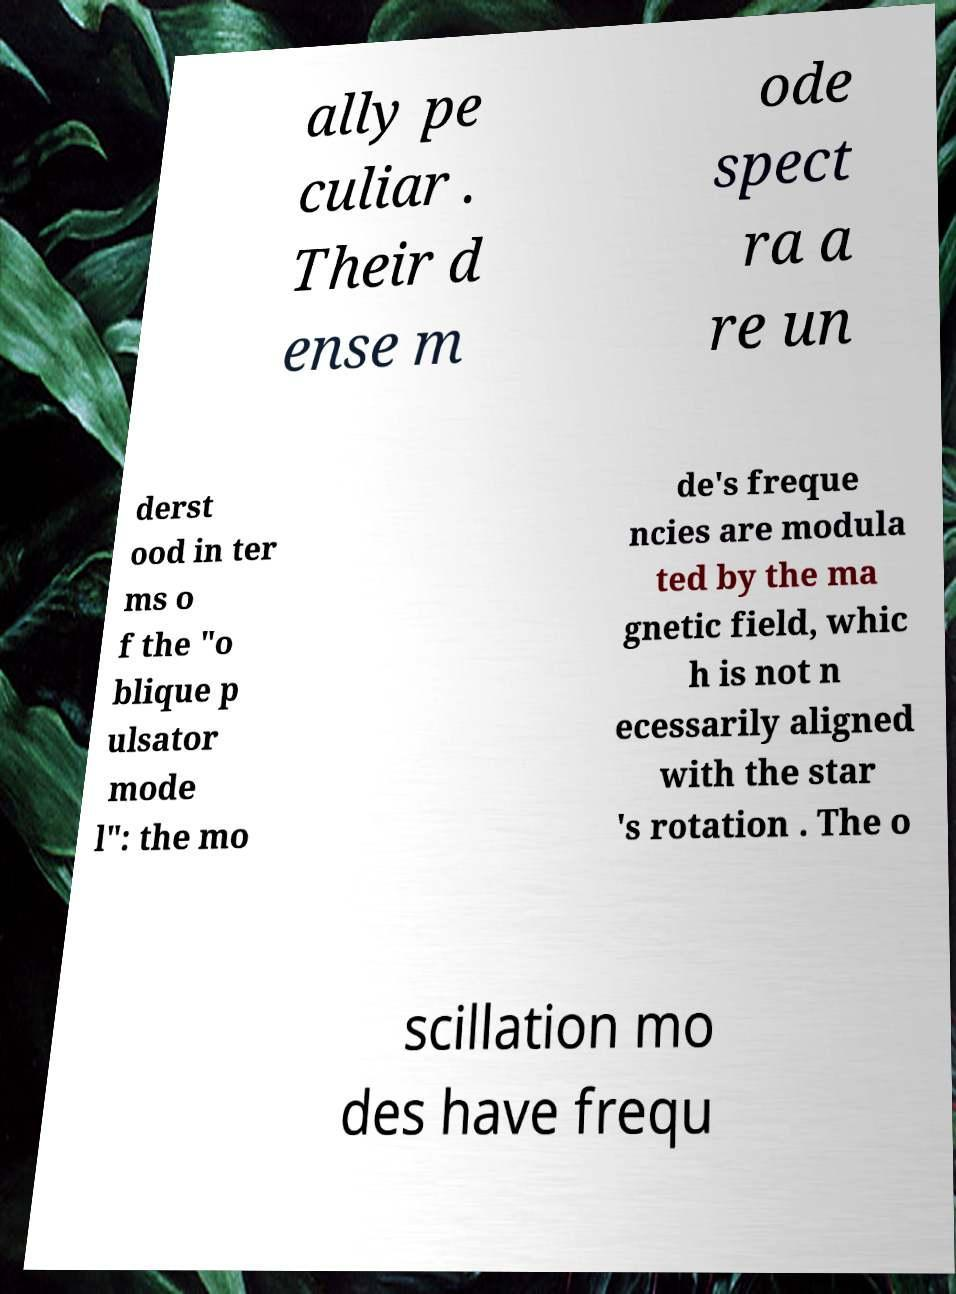Please read and relay the text visible in this image. What does it say? ally pe culiar . Their d ense m ode spect ra a re un derst ood in ter ms o f the "o blique p ulsator mode l": the mo de's freque ncies are modula ted by the ma gnetic field, whic h is not n ecessarily aligned with the star 's rotation . The o scillation mo des have frequ 